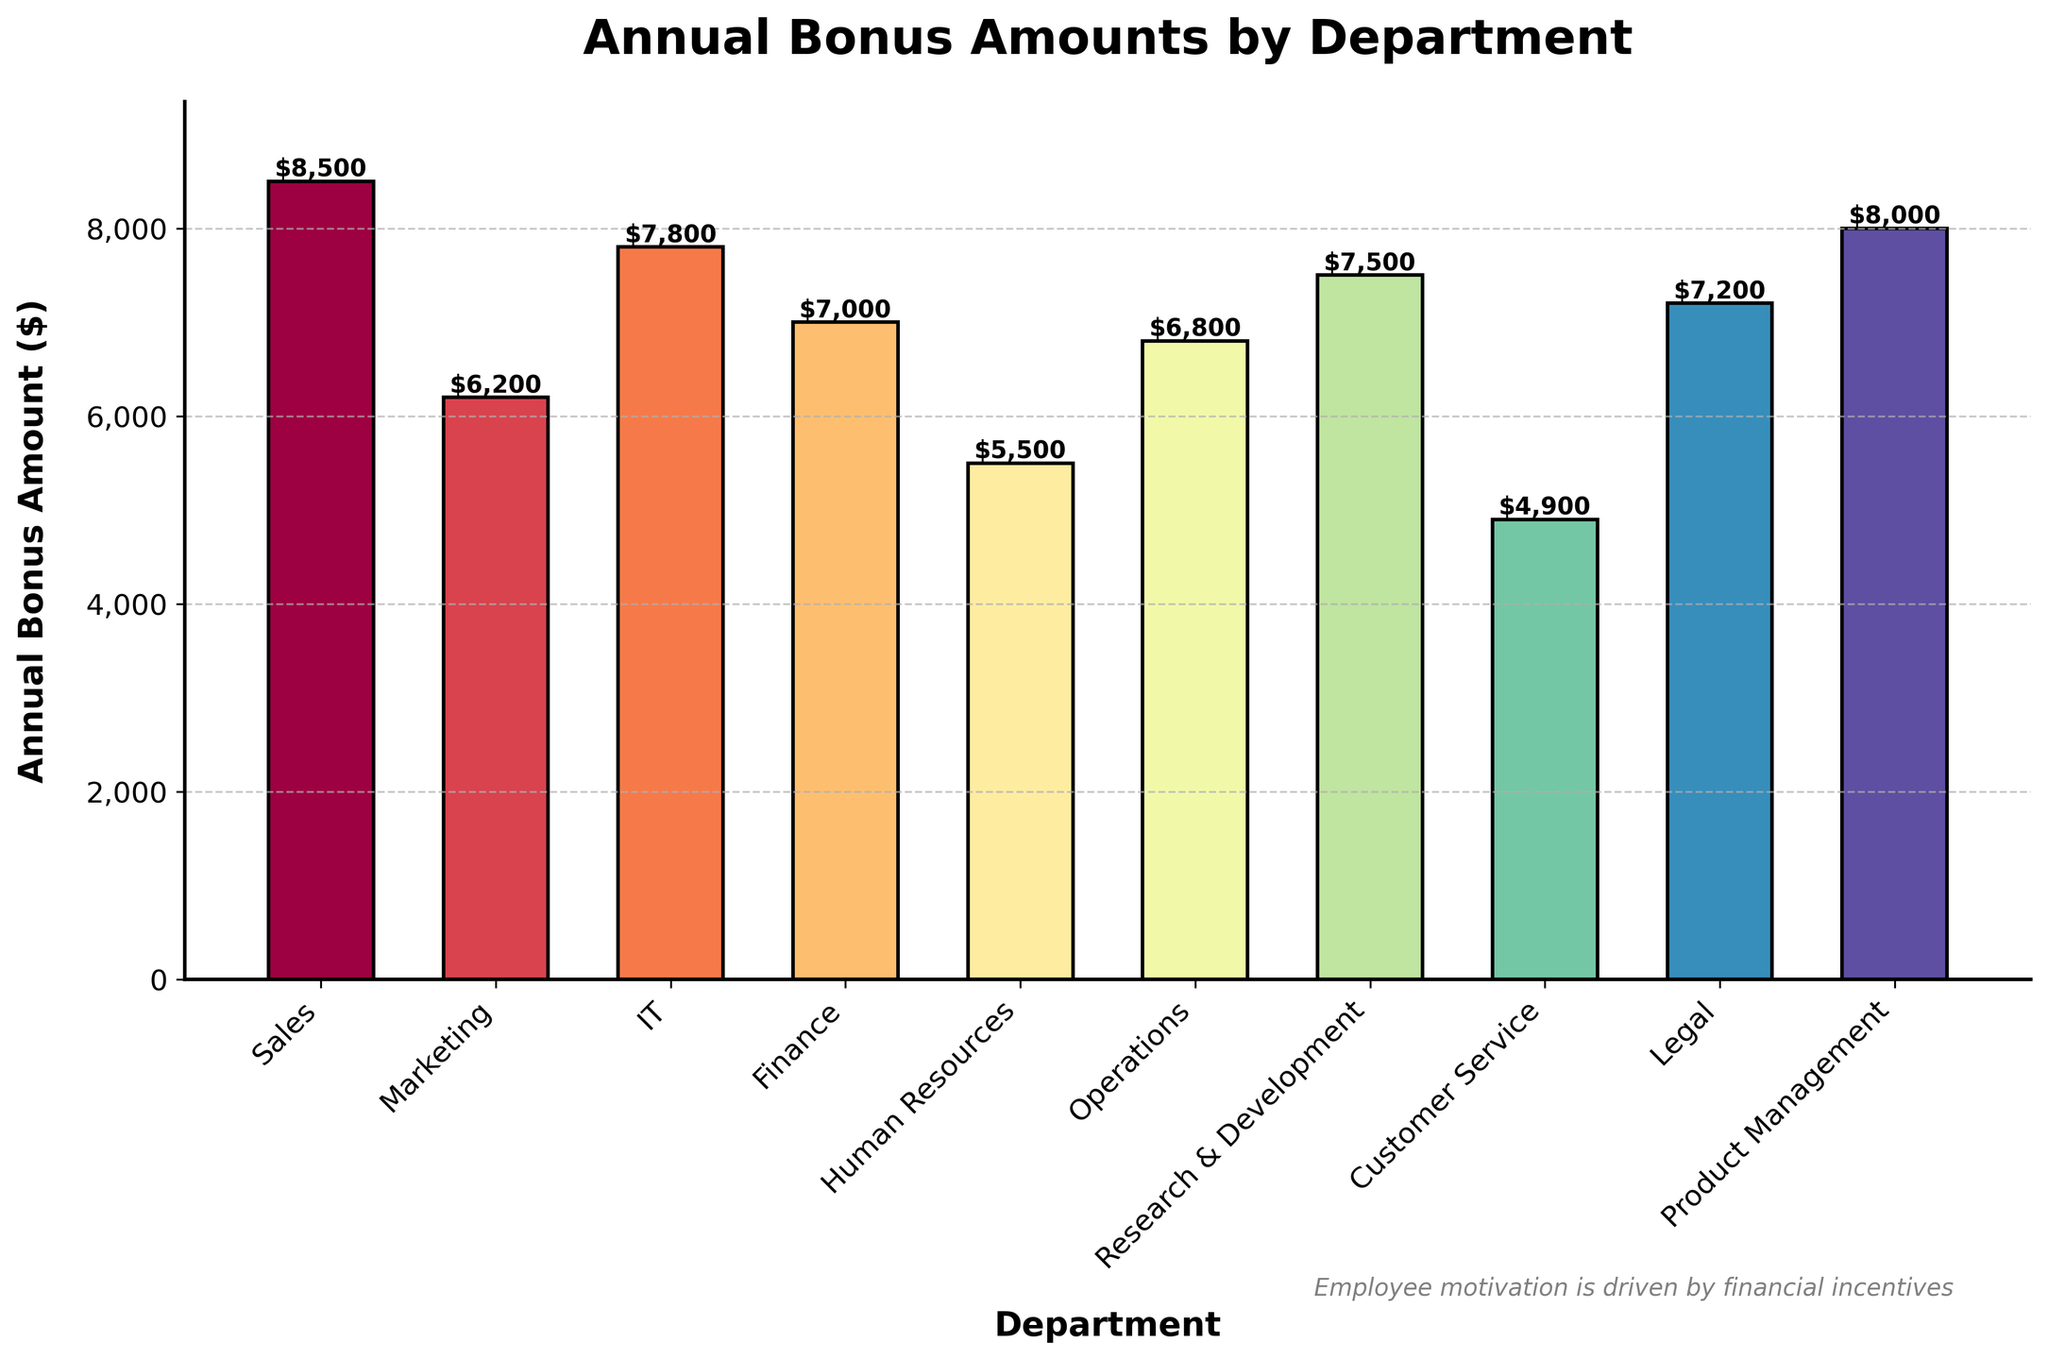Which department has the highest annual bonus amount? The bar chart shows that the Sales department has the highest bar indicating the highest annual bonus amount.
Answer: Sales How much more is the annual bonus amount for Sales than for Customer Service? The annual bonus amount for Sales is $8500, and for Customer Service, it is $4900. Subtracting the two values, $8500 - $4900 = $3600.
Answer: $3600 What is the total annual bonus amount for the IT and Research & Development departments combined? The IT department has an annual bonus amount of $7800, and Research & Development has $7500. Adding them together, $7800 + $7500 = $15300.
Answer: $15300 Which departments have annual bonus amounts greater than $7000? The departments with annual bonuses greater than $7000 are Sales ($8500), IT ($7800), Research & Development ($7500), Product Management ($8000), and Legal ($7200).
Answer: Sales, IT, Research & Development, Product Management, Legal What is the average annual bonus amount across all departments? The sum of the annual bonuses is $8500 + $6200 + $7800 + $7000 + $5500 + $6800 + $7500 + $4900 + $7200 + $8000 = $69400. There are 10 departments, so the average is $69400 / 10 = $6940.
Answer: $6940 Which department has the lowest annual bonus amount, and what is the amount? The bar chart shows that the Customer Service department has the shortest bar, indicating the lowest annual bonus amount of $4900.
Answer: Customer Service, $4900 How much more is the annual bonus amount for Sales compared to Marketing and Human Resources combined? The Sales department has an annual bonus amount of $8500. The Marketing department has $6200 and Human Resources has $5500, so combined they are $6200 + $5500 = $11700. The difference is $8500 - $11700, which actually shows that Sales has $3200 less annual bonus than the combined amount of Marketing and Human Resources.
Answer: $3200 less Which departments have the same annual bonus amount? The bar chart indicates that no two departments have the same annual bonus amount. Each department has a unique value.
Answer: None 